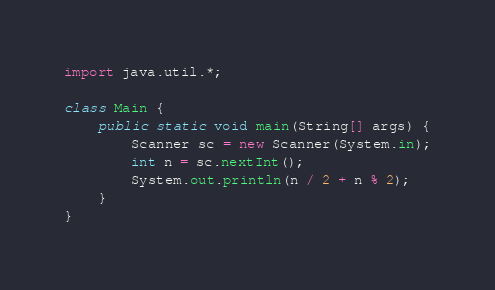Convert code to text. <code><loc_0><loc_0><loc_500><loc_500><_Java_>import java.util.*;

class Main {
    public static void main(String[] args) {
        Scanner sc = new Scanner(System.in);
        int n = sc.nextInt();
        System.out.println(n / 2 + n % 2);
    }
}</code> 